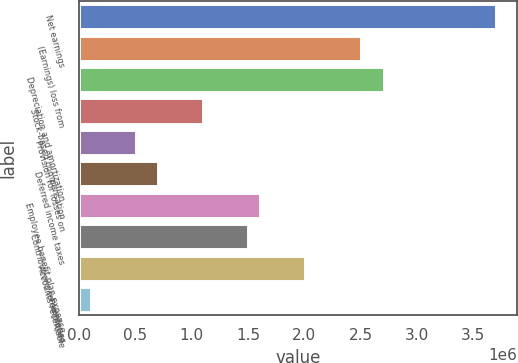<chart> <loc_0><loc_0><loc_500><loc_500><bar_chart><fcel>Net earnings<fcel>(Earnings) loss from<fcel>Depreciation and amortization<fcel>Stock-based compensation<fcel>Provision for losses on<fcel>Deferred income taxes<fcel>Employee benefit plan expense<fcel>Contributions to employee<fcel>Accounts receivable<fcel>Inventories<nl><fcel>3.70793e+06<fcel>2.5058e+06<fcel>2.70615e+06<fcel>1.10331e+06<fcel>502240<fcel>702596<fcel>1.6042e+06<fcel>1.50402e+06<fcel>2.00491e+06<fcel>101529<nl></chart> 